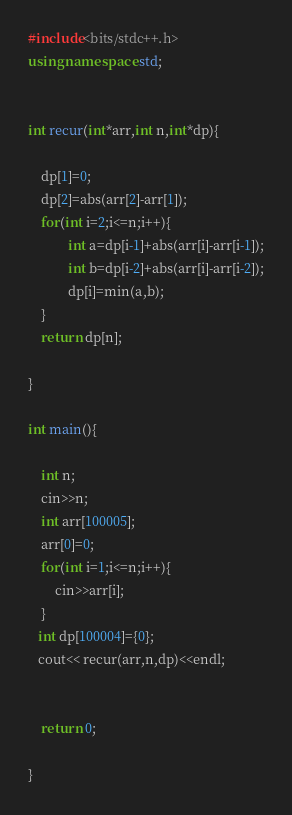<code> <loc_0><loc_0><loc_500><loc_500><_C++_>#include<bits/stdc++.h>
using namespace std;


int recur(int*arr,int n,int*dp){

	dp[1]=0;
	dp[2]=abs(arr[2]-arr[1]);
	for(int i=2;i<=n;i++){
			int a=dp[i-1]+abs(arr[i]-arr[i-1]);
			int b=dp[i-2]+abs(arr[i]-arr[i-2]);
			dp[i]=min(a,b);
	}
	return dp[n];

}

int main(){

	int n;
	cin>>n;
	int arr[100005];
	arr[0]=0;
	for(int i=1;i<=n;i++){
		cin>>arr[i];
	}
   int dp[100004]={0};
   cout<< recur(arr,n,dp)<<endl;
   

	return 0;

}
</code> 